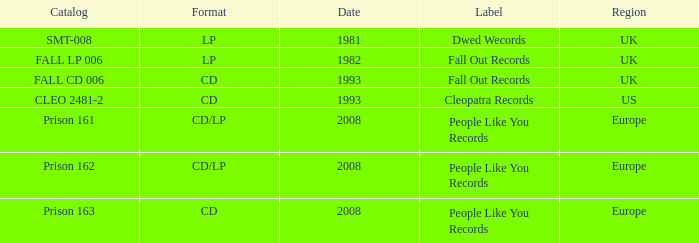Which Label has a Date smaller than 2008, and a Catalog of fall cd 006? Fall Out Records. 